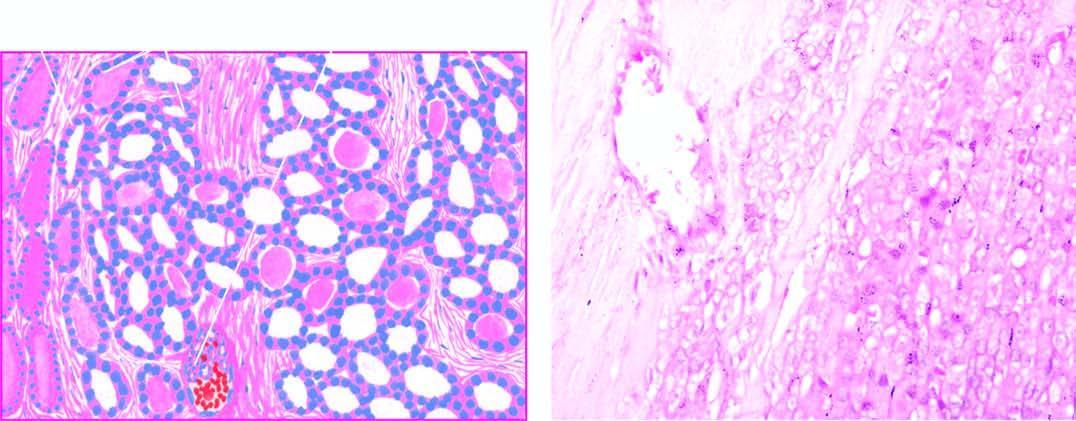what are of various sizes?
Answer the question using a single word or phrase. Follicles lined by tumour cells 